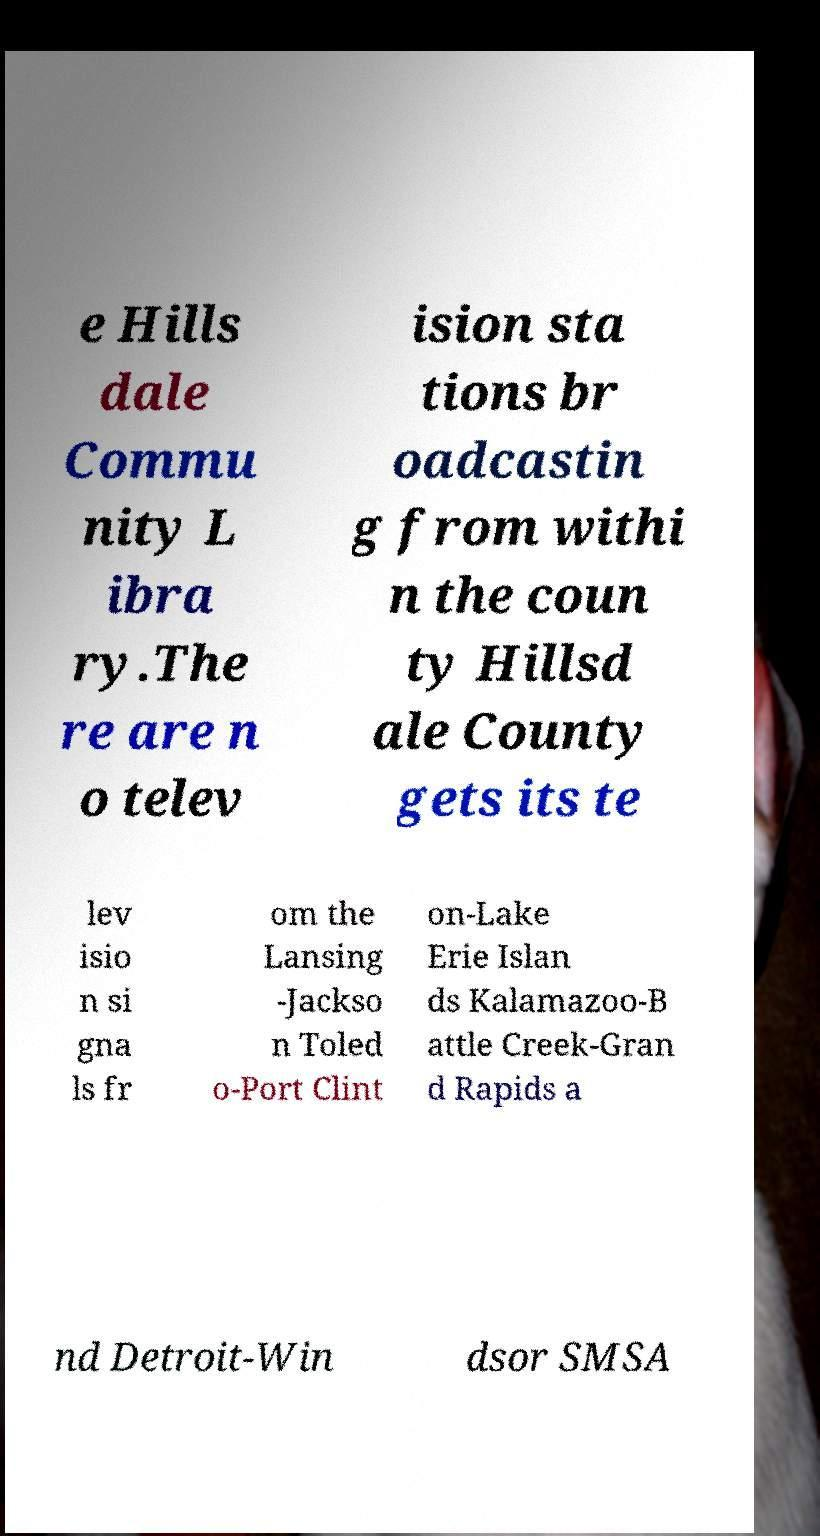There's text embedded in this image that I need extracted. Can you transcribe it verbatim? e Hills dale Commu nity L ibra ry.The re are n o telev ision sta tions br oadcastin g from withi n the coun ty Hillsd ale County gets its te lev isio n si gna ls fr om the Lansing -Jackso n Toled o-Port Clint on-Lake Erie Islan ds Kalamazoo-B attle Creek-Gran d Rapids a nd Detroit-Win dsor SMSA 